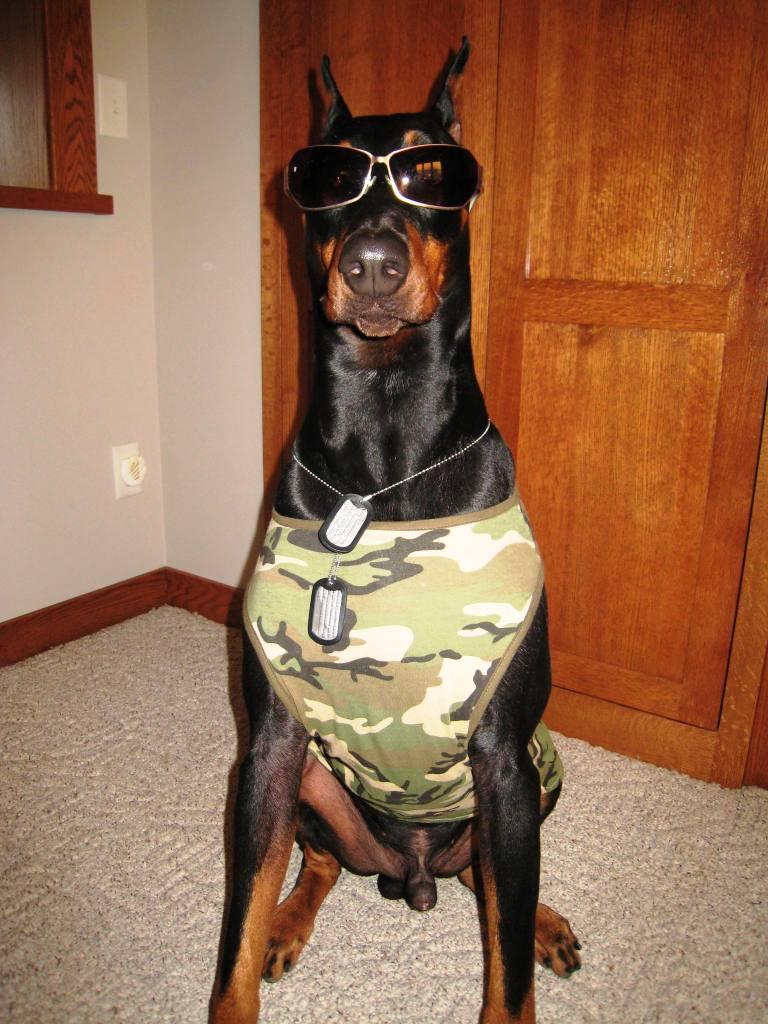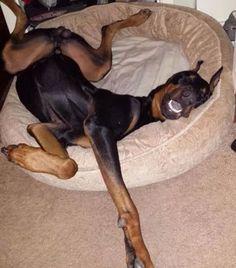The first image is the image on the left, the second image is the image on the right. Given the left and right images, does the statement "The right image contains a black and brown dog inside on a wooden floor." hold true? Answer yes or no. No. The first image is the image on the left, the second image is the image on the right. Examine the images to the left and right. Is the description "Both dogs are indoors." accurate? Answer yes or no. Yes. 